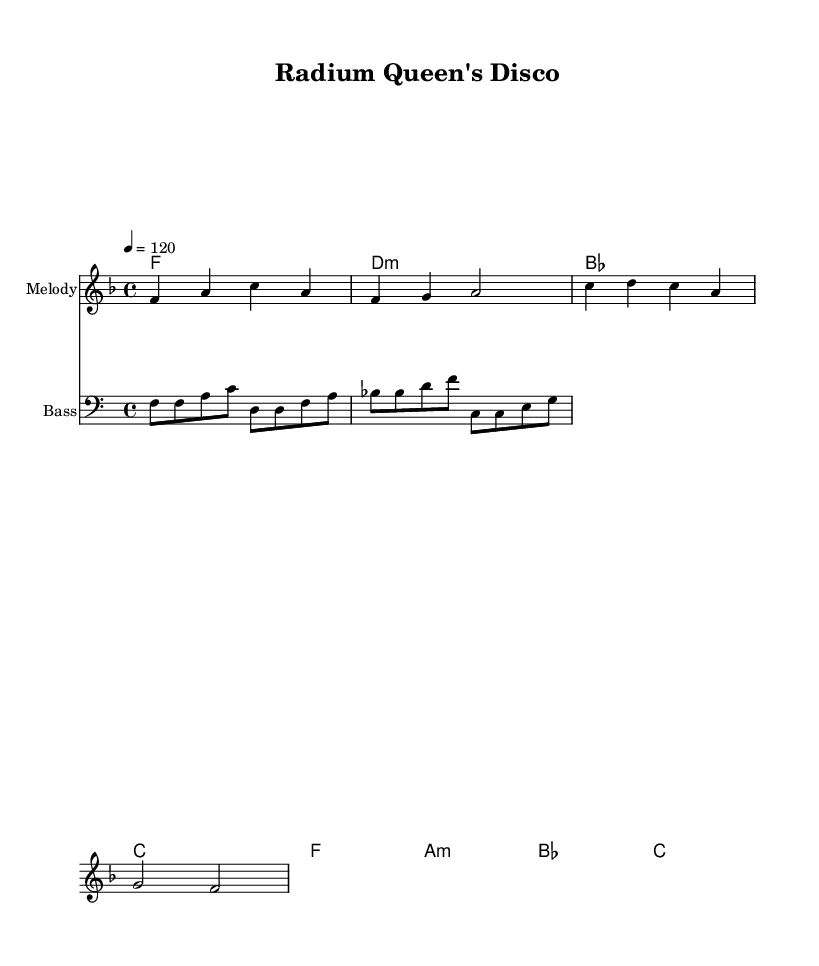What is the key signature of this music? The key signature has one flat, indicating it is in F major.
Answer: F major What is the time signature of this music? The time signature is indicated by the numbers at the beginning, showing it is in 4/4 time.
Answer: 4/4 What is the tempo marking in this piece? The tempo marking shows 4 equals 120, which indicates the beats per minute for the piece.
Answer: 120 How many measures are in the melody part? Counting the measures in the melody line, there are four measures in total.
Answer: 4 What chord follows D minor in the harmonic progression? The chords in the harmonic line show that D minor is followed by B flat major.
Answer: B flat major Which instrument plays the melody? The instrument indicated in the score specifically states that the melody is played by a staff labeled "Melody."
Answer: Melody What is the rhythmic value of the first note in the melody? The first note in the melody (F) is a quarter note, as indicated by its shape in the score.
Answer: Quarter note 